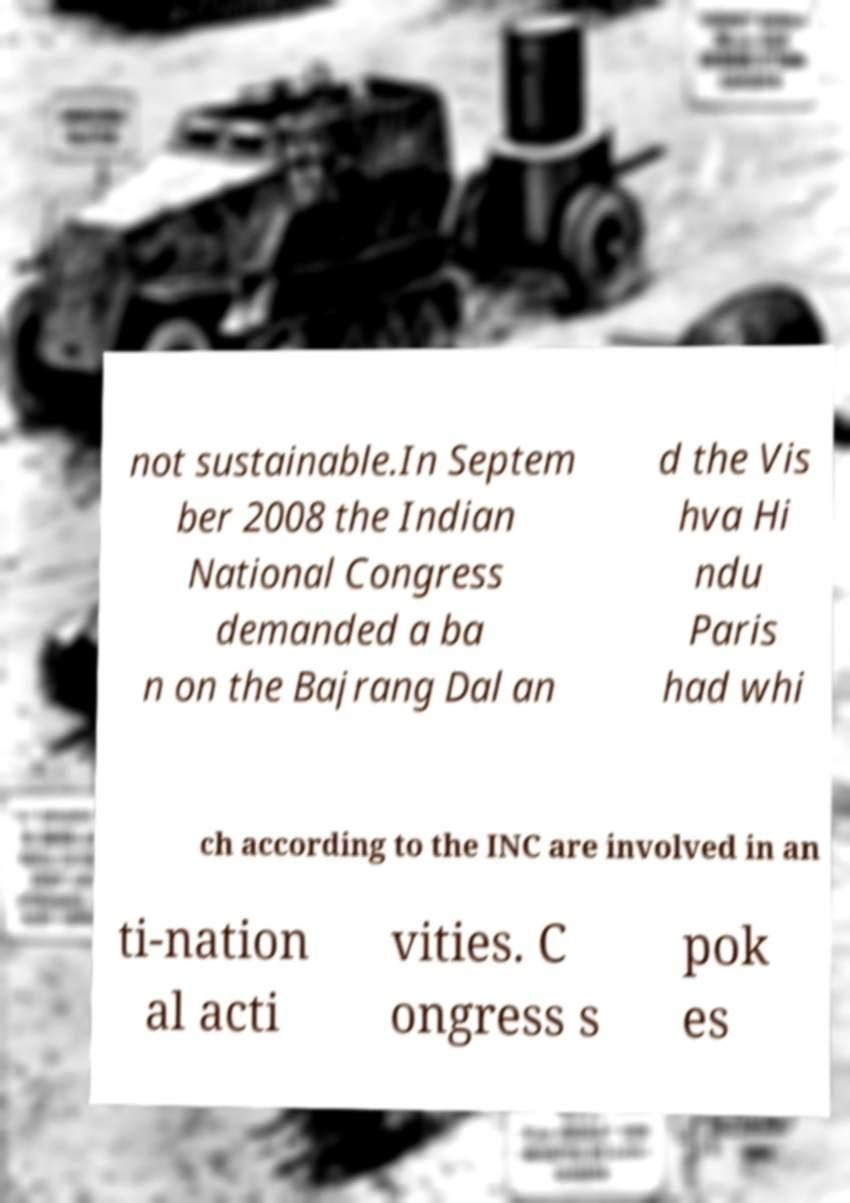I need the written content from this picture converted into text. Can you do that? not sustainable.In Septem ber 2008 the Indian National Congress demanded a ba n on the Bajrang Dal an d the Vis hva Hi ndu Paris had whi ch according to the INC are involved in an ti-nation al acti vities. C ongress s pok es 